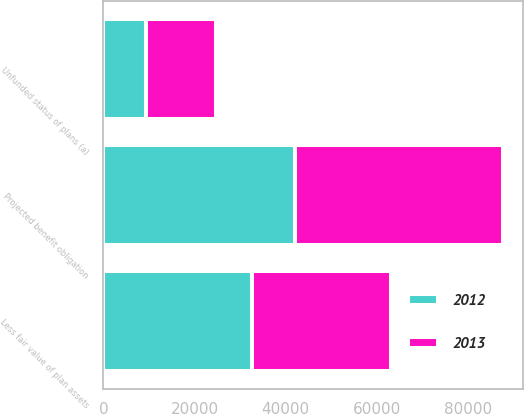<chart> <loc_0><loc_0><loc_500><loc_500><stacked_bar_chart><ecel><fcel>Projected benefit obligation<fcel>Less fair value of plan assets<fcel>Unfunded status of plans (a)<nl><fcel>2012<fcel>41984<fcel>32623<fcel>9361<nl><fcel>2013<fcel>45875<fcel>30597<fcel>15278<nl></chart> 